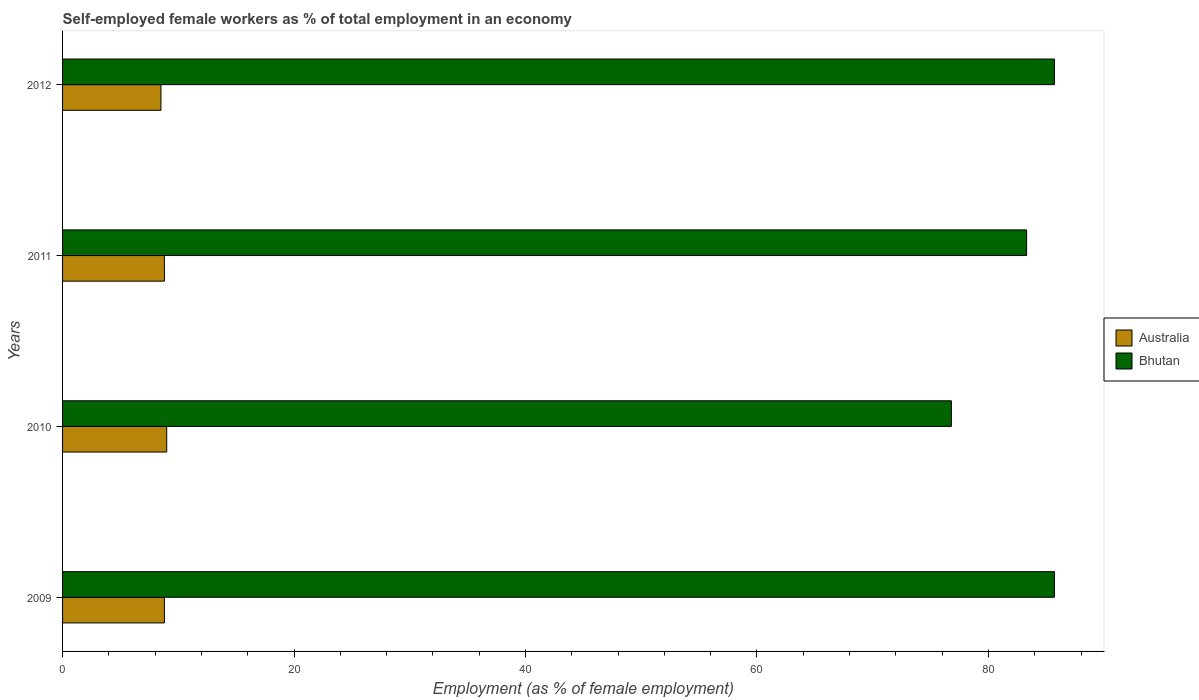How many groups of bars are there?
Your answer should be compact. 4. Are the number of bars per tick equal to the number of legend labels?
Make the answer very short. Yes. Are the number of bars on each tick of the Y-axis equal?
Your answer should be very brief. Yes. How many bars are there on the 4th tick from the bottom?
Give a very brief answer. 2. What is the percentage of self-employed female workers in Bhutan in 2011?
Ensure brevity in your answer.  83.3. Across all years, what is the maximum percentage of self-employed female workers in Australia?
Your response must be concise. 9. Across all years, what is the minimum percentage of self-employed female workers in Australia?
Your response must be concise. 8.5. In which year was the percentage of self-employed female workers in Bhutan maximum?
Your answer should be compact. 2009. In which year was the percentage of self-employed female workers in Bhutan minimum?
Make the answer very short. 2010. What is the total percentage of self-employed female workers in Australia in the graph?
Offer a terse response. 35.1. What is the difference between the percentage of self-employed female workers in Bhutan in 2009 and that in 2011?
Make the answer very short. 2.4. What is the difference between the percentage of self-employed female workers in Australia in 2010 and the percentage of self-employed female workers in Bhutan in 2009?
Offer a terse response. -76.7. What is the average percentage of self-employed female workers in Bhutan per year?
Keep it short and to the point. 82.88. In the year 2012, what is the difference between the percentage of self-employed female workers in Australia and percentage of self-employed female workers in Bhutan?
Your answer should be compact. -77.2. In how many years, is the percentage of self-employed female workers in Australia greater than 72 %?
Provide a short and direct response. 0. What is the ratio of the percentage of self-employed female workers in Australia in 2010 to that in 2012?
Make the answer very short. 1.06. Is the percentage of self-employed female workers in Bhutan in 2009 less than that in 2011?
Keep it short and to the point. No. What is the difference between the highest and the second highest percentage of self-employed female workers in Australia?
Your response must be concise. 0.2. What is the difference between the highest and the lowest percentage of self-employed female workers in Australia?
Make the answer very short. 0.5. What does the 1st bar from the top in 2009 represents?
Offer a terse response. Bhutan. Are all the bars in the graph horizontal?
Offer a terse response. Yes. How many years are there in the graph?
Provide a succinct answer. 4. What is the title of the graph?
Offer a very short reply. Self-employed female workers as % of total employment in an economy. Does "Fiji" appear as one of the legend labels in the graph?
Offer a very short reply. No. What is the label or title of the X-axis?
Provide a succinct answer. Employment (as % of female employment). What is the Employment (as % of female employment) of Australia in 2009?
Keep it short and to the point. 8.8. What is the Employment (as % of female employment) in Bhutan in 2009?
Offer a very short reply. 85.7. What is the Employment (as % of female employment) of Australia in 2010?
Your response must be concise. 9. What is the Employment (as % of female employment) of Bhutan in 2010?
Ensure brevity in your answer.  76.8. What is the Employment (as % of female employment) in Australia in 2011?
Ensure brevity in your answer.  8.8. What is the Employment (as % of female employment) in Bhutan in 2011?
Offer a terse response. 83.3. What is the Employment (as % of female employment) in Australia in 2012?
Your response must be concise. 8.5. What is the Employment (as % of female employment) of Bhutan in 2012?
Give a very brief answer. 85.7. Across all years, what is the maximum Employment (as % of female employment) in Bhutan?
Keep it short and to the point. 85.7. Across all years, what is the minimum Employment (as % of female employment) of Australia?
Ensure brevity in your answer.  8.5. Across all years, what is the minimum Employment (as % of female employment) in Bhutan?
Offer a very short reply. 76.8. What is the total Employment (as % of female employment) in Australia in the graph?
Your response must be concise. 35.1. What is the total Employment (as % of female employment) in Bhutan in the graph?
Offer a terse response. 331.5. What is the difference between the Employment (as % of female employment) in Australia in 2009 and that in 2011?
Your answer should be very brief. 0. What is the difference between the Employment (as % of female employment) of Australia in 2010 and that in 2011?
Provide a succinct answer. 0.2. What is the difference between the Employment (as % of female employment) of Bhutan in 2010 and that in 2012?
Keep it short and to the point. -8.9. What is the difference between the Employment (as % of female employment) of Australia in 2011 and that in 2012?
Ensure brevity in your answer.  0.3. What is the difference between the Employment (as % of female employment) in Australia in 2009 and the Employment (as % of female employment) in Bhutan in 2010?
Your response must be concise. -68. What is the difference between the Employment (as % of female employment) in Australia in 2009 and the Employment (as % of female employment) in Bhutan in 2011?
Your answer should be compact. -74.5. What is the difference between the Employment (as % of female employment) of Australia in 2009 and the Employment (as % of female employment) of Bhutan in 2012?
Offer a terse response. -76.9. What is the difference between the Employment (as % of female employment) of Australia in 2010 and the Employment (as % of female employment) of Bhutan in 2011?
Make the answer very short. -74.3. What is the difference between the Employment (as % of female employment) in Australia in 2010 and the Employment (as % of female employment) in Bhutan in 2012?
Your response must be concise. -76.7. What is the difference between the Employment (as % of female employment) in Australia in 2011 and the Employment (as % of female employment) in Bhutan in 2012?
Your response must be concise. -76.9. What is the average Employment (as % of female employment) of Australia per year?
Ensure brevity in your answer.  8.78. What is the average Employment (as % of female employment) in Bhutan per year?
Provide a short and direct response. 82.88. In the year 2009, what is the difference between the Employment (as % of female employment) in Australia and Employment (as % of female employment) in Bhutan?
Your response must be concise. -76.9. In the year 2010, what is the difference between the Employment (as % of female employment) of Australia and Employment (as % of female employment) of Bhutan?
Your answer should be compact. -67.8. In the year 2011, what is the difference between the Employment (as % of female employment) of Australia and Employment (as % of female employment) of Bhutan?
Make the answer very short. -74.5. In the year 2012, what is the difference between the Employment (as % of female employment) of Australia and Employment (as % of female employment) of Bhutan?
Your answer should be very brief. -77.2. What is the ratio of the Employment (as % of female employment) of Australia in 2009 to that in 2010?
Provide a short and direct response. 0.98. What is the ratio of the Employment (as % of female employment) of Bhutan in 2009 to that in 2010?
Offer a very short reply. 1.12. What is the ratio of the Employment (as % of female employment) of Bhutan in 2009 to that in 2011?
Ensure brevity in your answer.  1.03. What is the ratio of the Employment (as % of female employment) of Australia in 2009 to that in 2012?
Your response must be concise. 1.04. What is the ratio of the Employment (as % of female employment) in Australia in 2010 to that in 2011?
Your answer should be very brief. 1.02. What is the ratio of the Employment (as % of female employment) in Bhutan in 2010 to that in 2011?
Your answer should be very brief. 0.92. What is the ratio of the Employment (as % of female employment) of Australia in 2010 to that in 2012?
Offer a terse response. 1.06. What is the ratio of the Employment (as % of female employment) in Bhutan in 2010 to that in 2012?
Offer a very short reply. 0.9. What is the ratio of the Employment (as % of female employment) of Australia in 2011 to that in 2012?
Make the answer very short. 1.04. What is the ratio of the Employment (as % of female employment) of Bhutan in 2011 to that in 2012?
Offer a very short reply. 0.97. What is the difference between the highest and the second highest Employment (as % of female employment) in Bhutan?
Give a very brief answer. 0. What is the difference between the highest and the lowest Employment (as % of female employment) of Bhutan?
Ensure brevity in your answer.  8.9. 